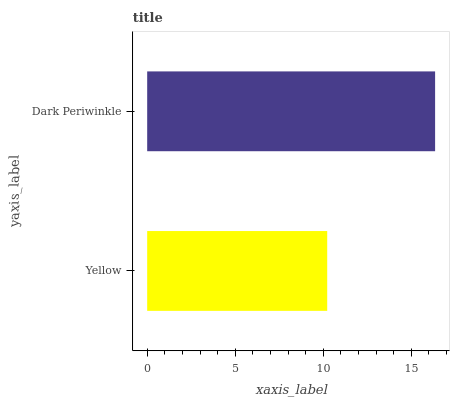Is Yellow the minimum?
Answer yes or no. Yes. Is Dark Periwinkle the maximum?
Answer yes or no. Yes. Is Dark Periwinkle the minimum?
Answer yes or no. No. Is Dark Periwinkle greater than Yellow?
Answer yes or no. Yes. Is Yellow less than Dark Periwinkle?
Answer yes or no. Yes. Is Yellow greater than Dark Periwinkle?
Answer yes or no. No. Is Dark Periwinkle less than Yellow?
Answer yes or no. No. Is Dark Periwinkle the high median?
Answer yes or no. Yes. Is Yellow the low median?
Answer yes or no. Yes. Is Yellow the high median?
Answer yes or no. No. Is Dark Periwinkle the low median?
Answer yes or no. No. 